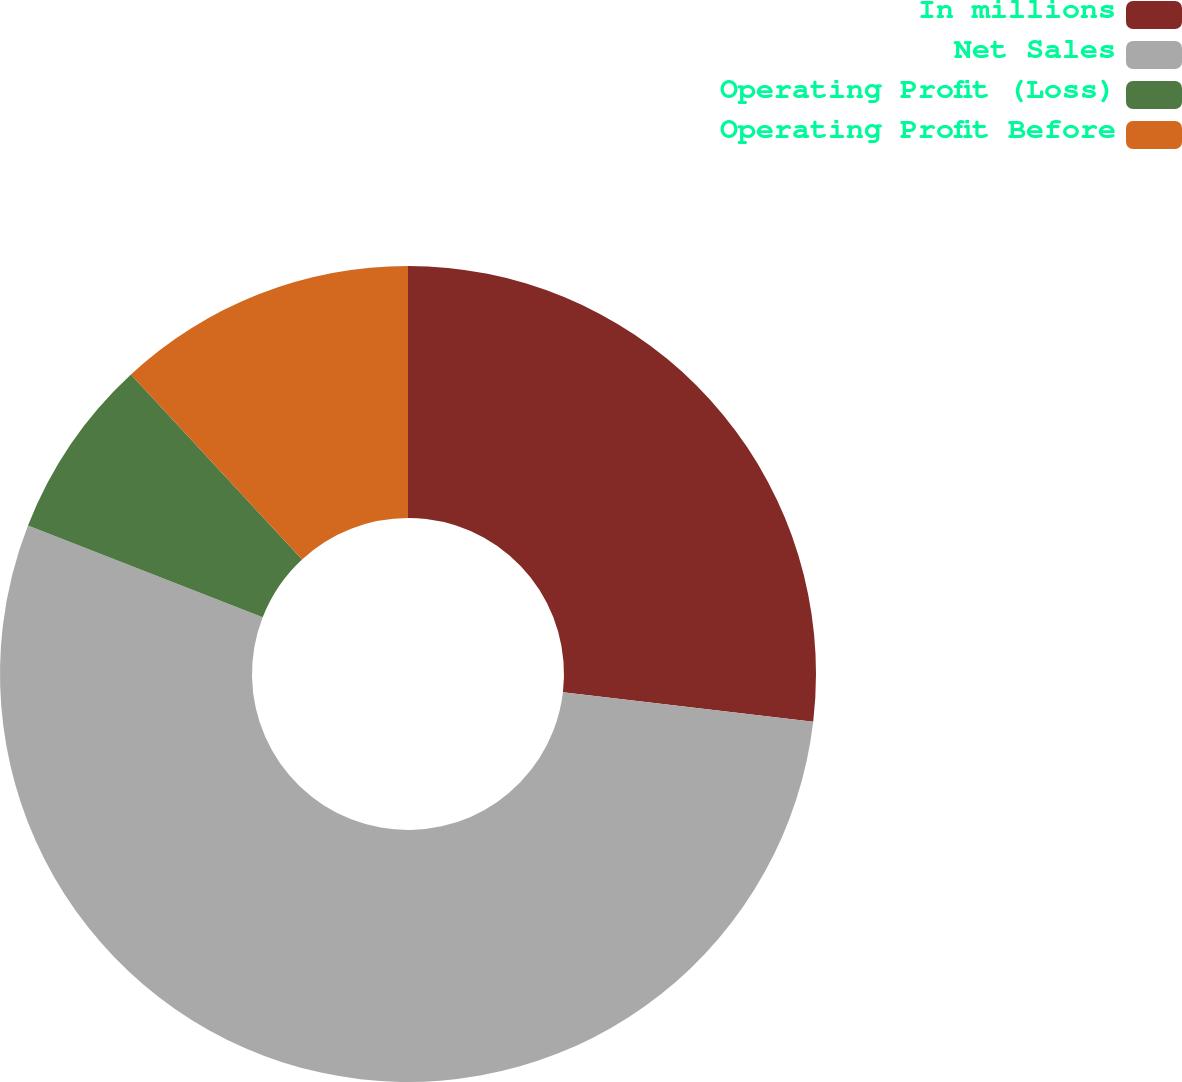Convert chart to OTSL. <chart><loc_0><loc_0><loc_500><loc_500><pie_chart><fcel>In millions<fcel>Net Sales<fcel>Operating Profit (Loss)<fcel>Operating Profit Before<nl><fcel>26.86%<fcel>54.06%<fcel>7.19%<fcel>11.88%<nl></chart> 